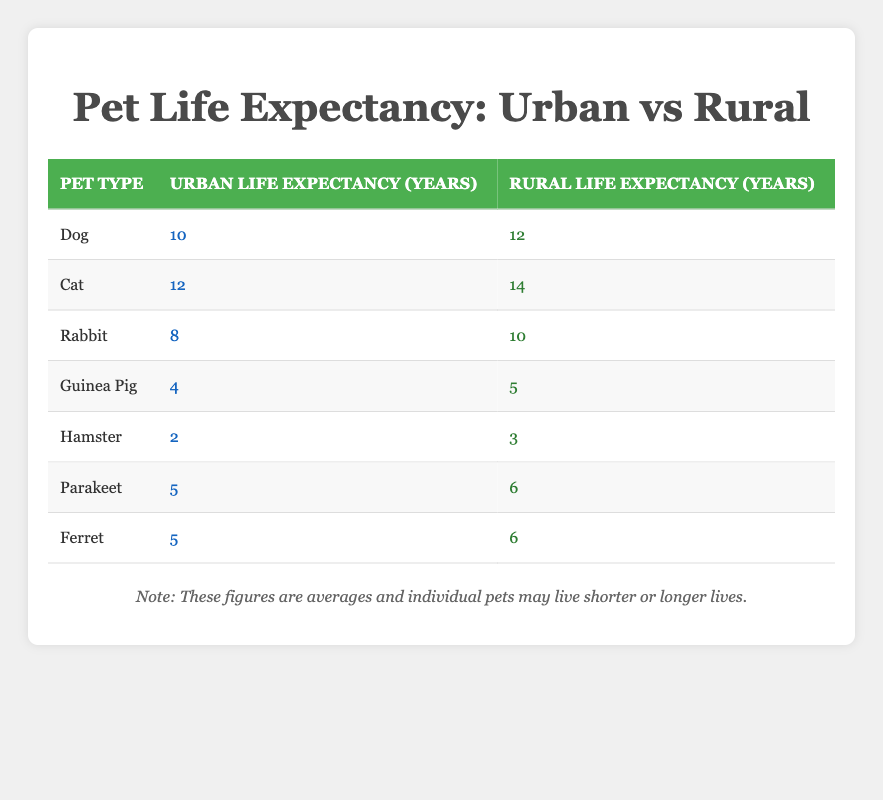What is the urban life expectancy of a dog? The table shows that the urban life expectancy of a dog is listed under the "Urban Life Expectancy (Years)" column corresponding to the dog row, which is 10 years.
Answer: 10 What pet has the shortest urban life expectancy? By reviewing the urban life expectancy values in the table, the values are 10 for dogs, 12 for cats, 8 for rabbits, 4 for guinea pigs, 2 for hamsters, 5 for parakeets, and 5 for ferrets. The lowest value is for hamsters, which is 2 years.
Answer: Hamster Does a cat live longer in rural areas compared to urban areas? For cats, the rural life expectancy listed is 14 years, while the urban expectation is 12 years. Since 14 is greater than 12, yes, cats live longer in rural areas.
Answer: Yes What is the difference in life expectancy for rabbits between urban and rural settings? The urban life expectancy for rabbits is 8 years, and the rural is 10 years. To find the difference, we subtract the urban value from the rural value: 10 - 8 = 2 years.
Answer: 2 years Are guinea pigs expected to live longer in urban areas than hamsters? The table states that guinea pigs have an urban life expectancy of 4 years while hamsters have 2 years. Since 4 is greater than 2, guinea pigs do live longer in urban areas than hamsters.
Answer: Yes What is the average urban life expectancy of all the pets listed? To find the average urban life expectancy, we add the values: 10 (dog) + 12 (cat) + 8 (rabbit) + 4 (guinea pig) + 2 (hamster) + 5 (parakeet) + 5 (ferret) = 46. There are 7 pets, so the average is 46 / 7 ≈ 6.57 years.
Answer: Approximately 6.57 years Is the life expectancy of ferrets higher in urban settings compared to guinea pigs? Ferrets have an urban life expectancy of 5 years, and guinea pigs have 4 years. Since 5 is greater than 4, ferrets do have a higher life expectancy in urban settings.
Answer: Yes What is the sum of the life expectancy of all pets in rural areas? The rural life expectancies are: 12 (dog) + 14 (cat) + 10 (rabbit) + 5 (guinea pig) + 3 (hamster) + 6 (parakeet) + 6 (ferret) = 56 years total.
Answer: 56 years 